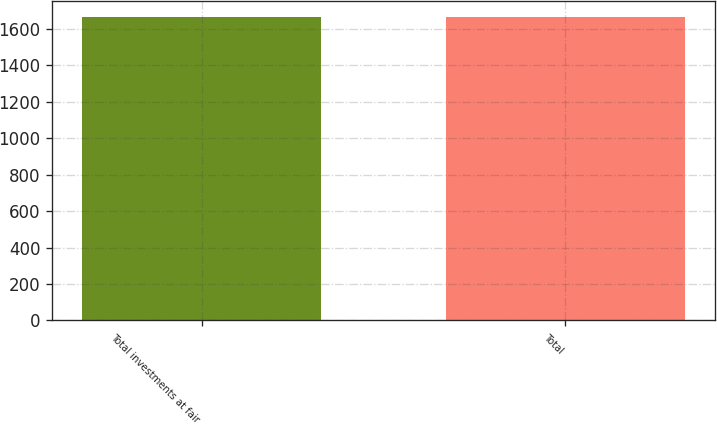<chart> <loc_0><loc_0><loc_500><loc_500><bar_chart><fcel>Total investments at fair<fcel>Total<nl><fcel>1667.3<fcel>1667.4<nl></chart> 